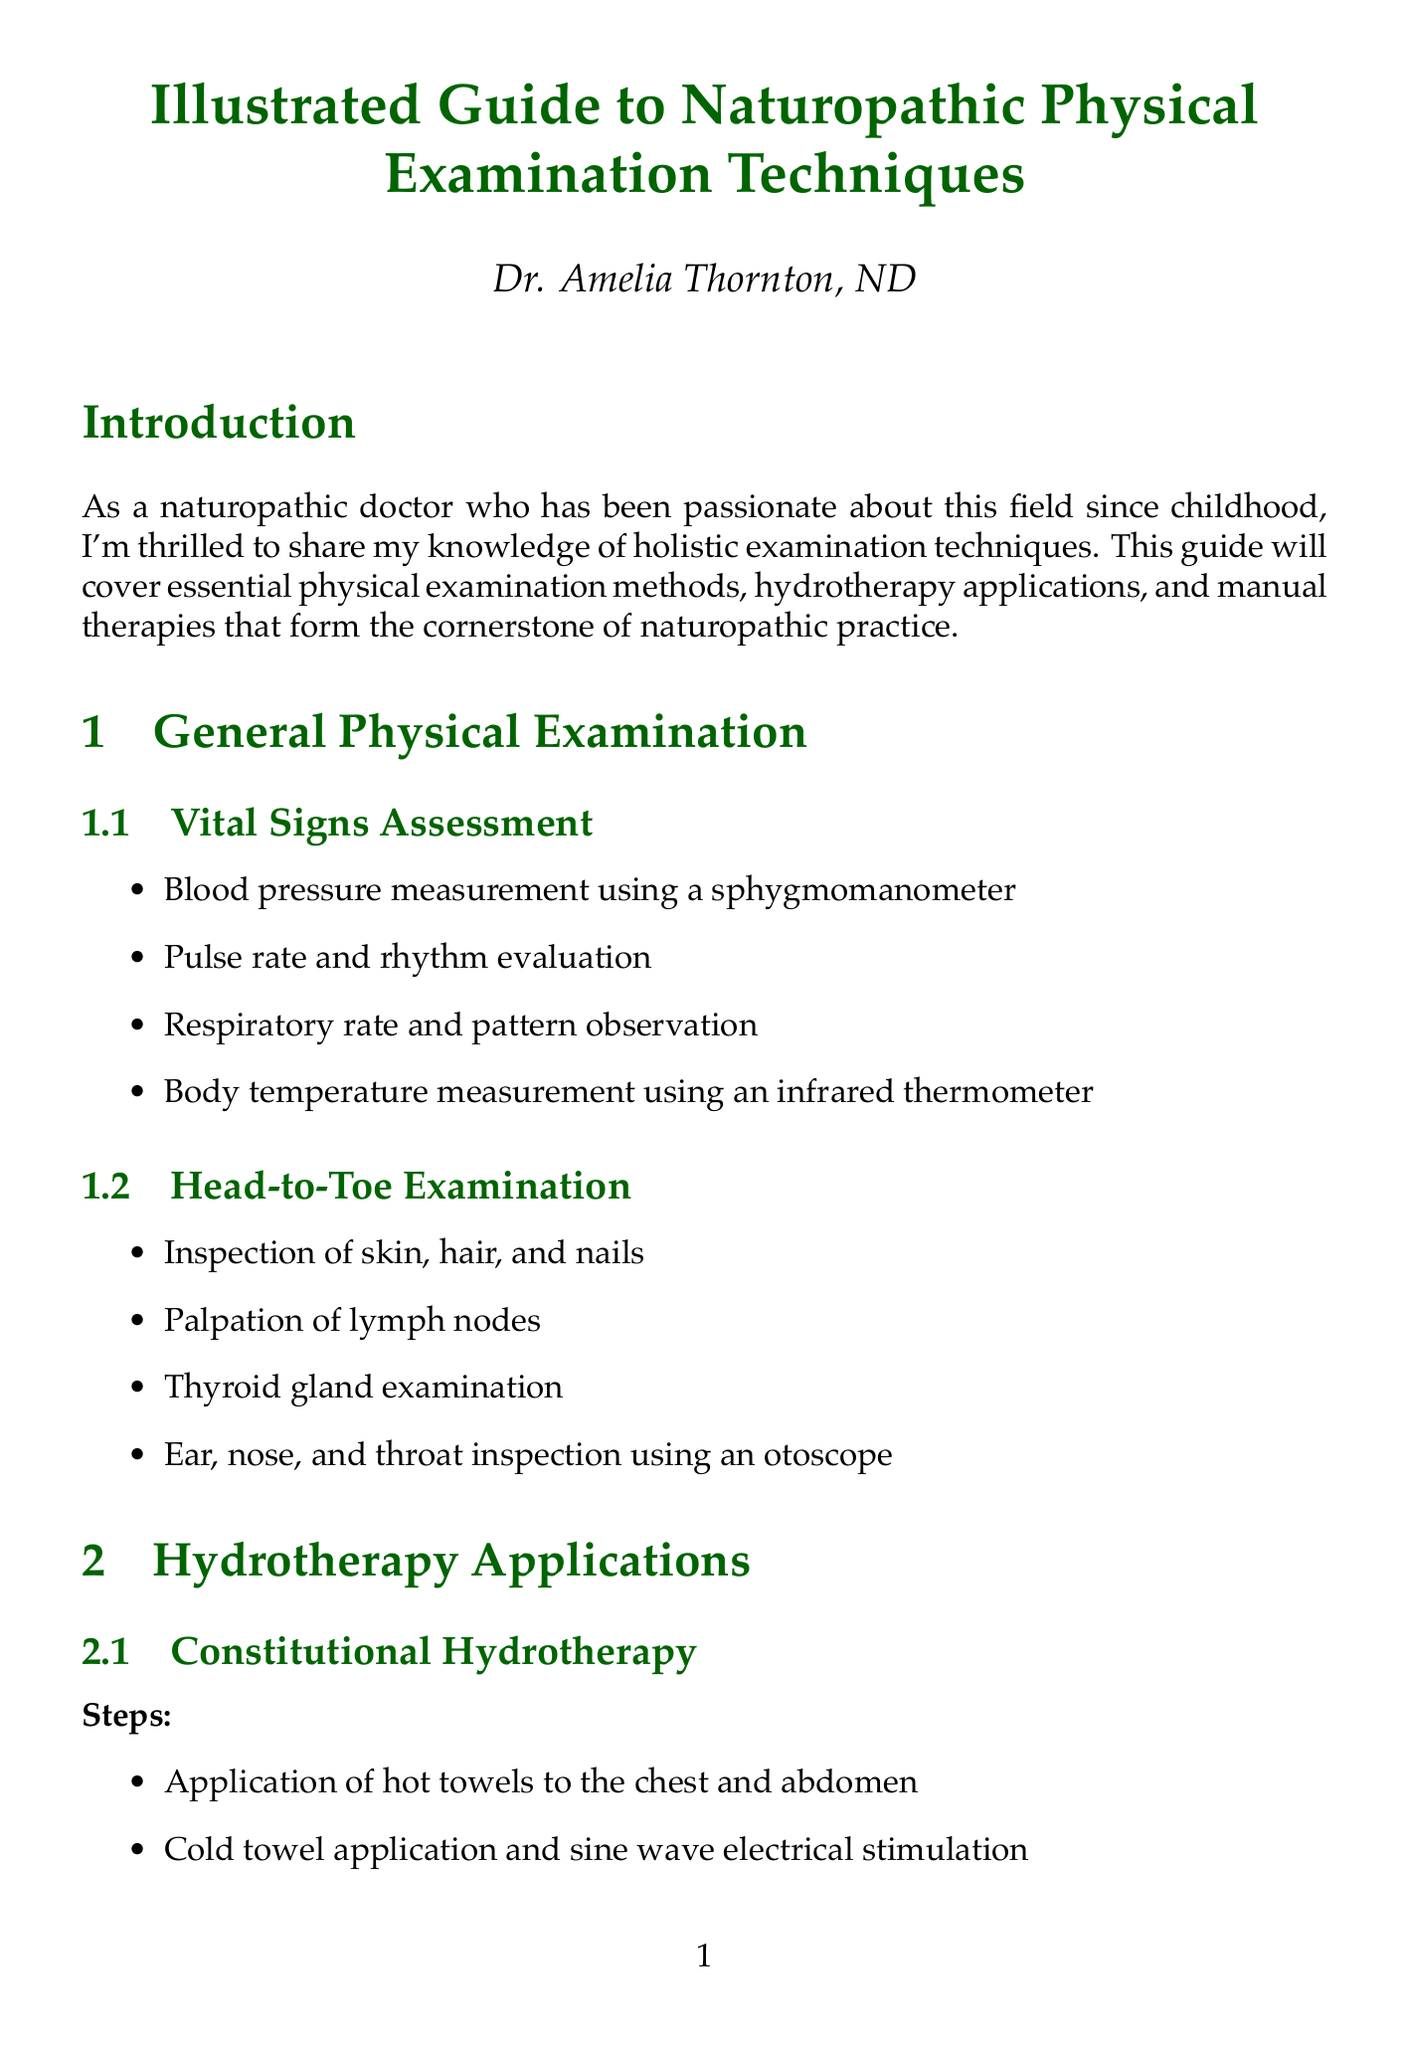What is the title of the guide? The title of the guide is provided at the beginning of the document.
Answer: Illustrated Guide to Naturopathic Physical Examination Techniques Who is the author of the guide? The author is mentioned at the title section of the document.
Answer: Dr. Amelia Thornton, ND What is one technique used in Vital Signs Assessment? The techniques are listed under the General Physical Examination section.
Answer: Blood pressure measurement using a sphygmomanometer What is a benefit of Constitutional Hydrotherapy? Benefits are listed specifically under the Hydrotherapy Applications section.
Answer: Enhances immune function What patient age is mentioned in the first case study? The age of the patient is included in the case studies section of the document.
Answer: 35-year-old What technique involves muscle testing? Techniques are outlined in the Special Diagnostic Procedures section.
Answer: Applied Kinesiology What is a safety consideration for Spinal Manipulation? Safety considerations are provided under the Manual Therapies section.
Answer: Contraindications for patients with osteoporosis What components are integrated to develop a treatment plan? Steps are outlined in the Integration of Examination Findings section.
Answer: Synthesizing information from multiple examination techniques 